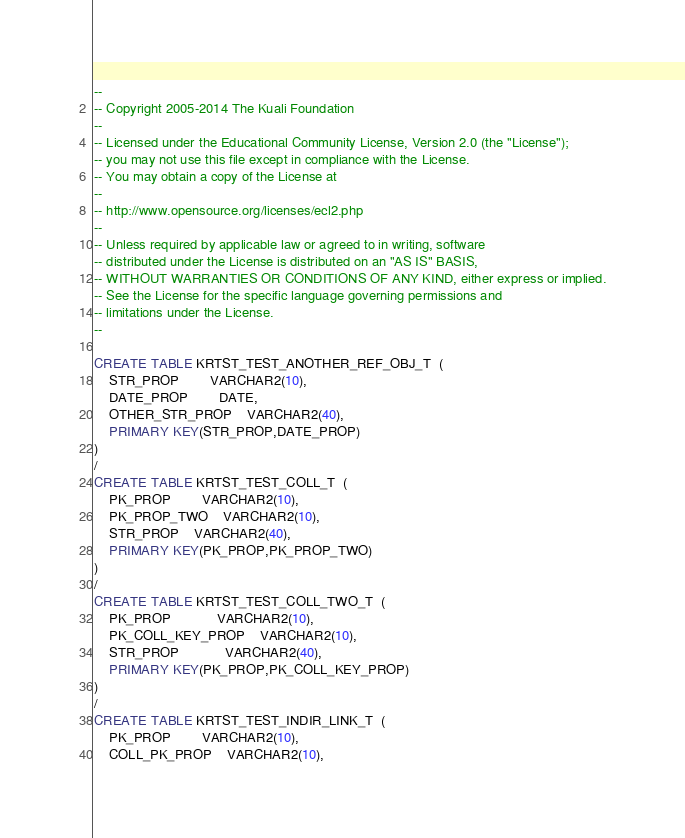Convert code to text. <code><loc_0><loc_0><loc_500><loc_500><_SQL_>--
-- Copyright 2005-2014 The Kuali Foundation
--
-- Licensed under the Educational Community License, Version 2.0 (the "License");
-- you may not use this file except in compliance with the License.
-- You may obtain a copy of the License at
--
-- http://www.opensource.org/licenses/ecl2.php
--
-- Unless required by applicable law or agreed to in writing, software
-- distributed under the License is distributed on an "AS IS" BASIS,
-- WITHOUT WARRANTIES OR CONDITIONS OF ANY KIND, either express or implied.
-- See the License for the specific language governing permissions and
-- limitations under the License.
--

CREATE TABLE KRTST_TEST_ANOTHER_REF_OBJ_T  ( 
    STR_PROP      	VARCHAR2(10),
    DATE_PROP     	DATE,
    OTHER_STR_PROP	VARCHAR2(40),
    PRIMARY KEY(STR_PROP,DATE_PROP)
)
/
CREATE TABLE KRTST_TEST_COLL_T  ( 
    PK_PROP    	VARCHAR2(10),
    PK_PROP_TWO	VARCHAR2(10),
    STR_PROP   	VARCHAR2(40),
    PRIMARY KEY(PK_PROP,PK_PROP_TWO)
)
/
CREATE TABLE KRTST_TEST_COLL_TWO_T  ( 
    PK_PROP         	VARCHAR2(10),
    PK_COLL_KEY_PROP	VARCHAR2(10),
    STR_PROP        	VARCHAR2(40),
    PRIMARY KEY(PK_PROP,PK_COLL_KEY_PROP)
)
/
CREATE TABLE KRTST_TEST_INDIR_LINK_T  ( 
    PK_PROP     	VARCHAR2(10),
    COLL_PK_PROP	VARCHAR2(10),</code> 